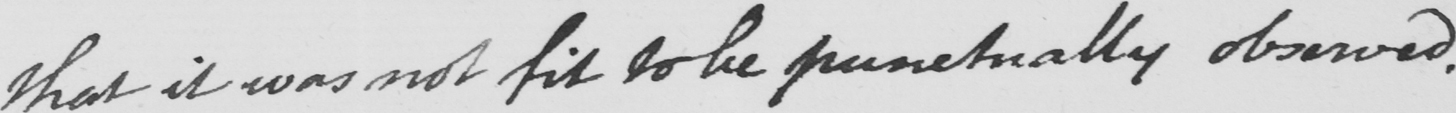What is written in this line of handwriting? that it was not fit to be punctually observed . 